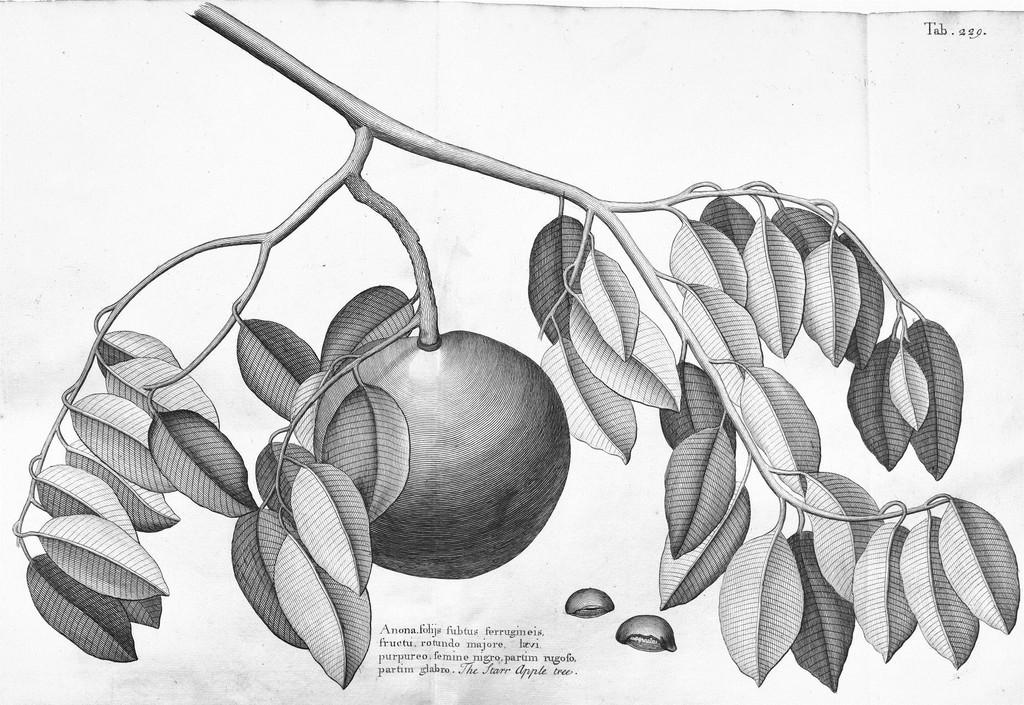What is depicted in the image? There is a sketch of a plant in the image. What can be observed on the plant in the sketch? The plant has a fruit on it. Is there any additional information or markings in the image? Yes, there is a watermark in the image. What is the color scheme of the image? The image is black and white in color. What type of fear can be seen on the face of the chicken in the image? There is no chicken present in the image; it features a sketch of a plant with a fruit. 